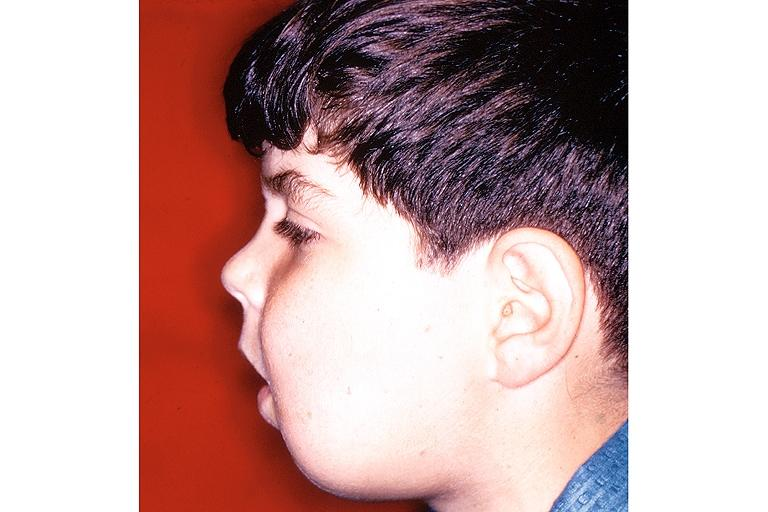s underdevelopment present?
Answer the question using a single word or phrase. No 